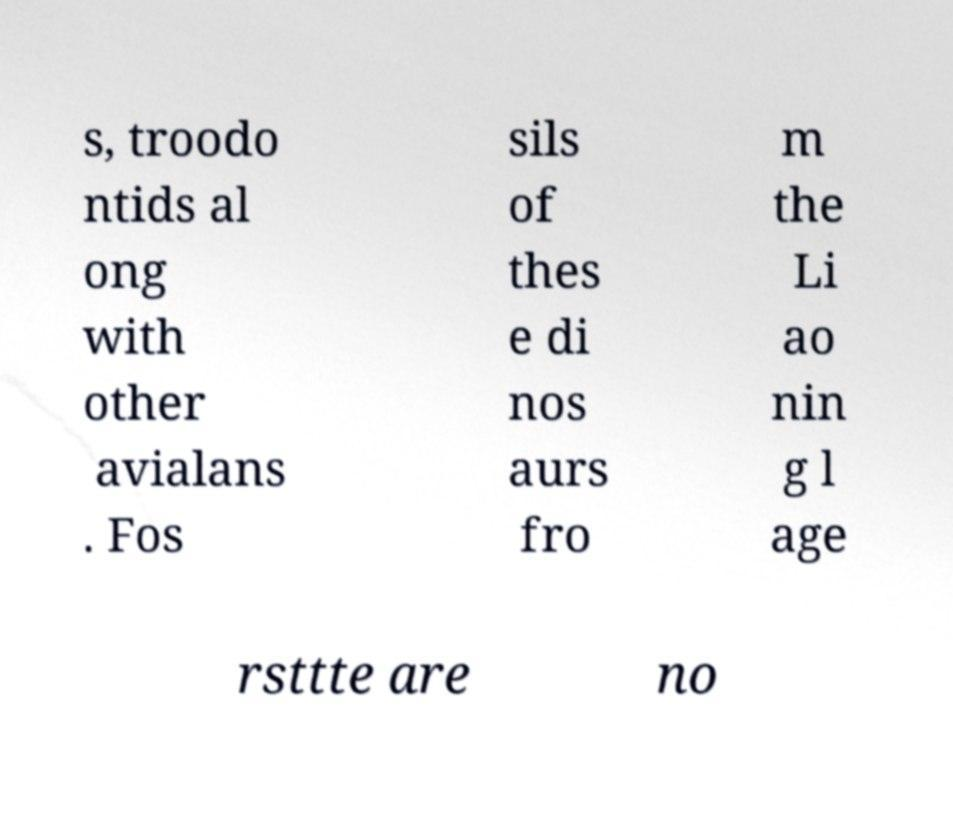Please read and relay the text visible in this image. What does it say? s, troodo ntids al ong with other avialans . Fos sils of thes e di nos aurs fro m the Li ao nin g l age rsttte are no 